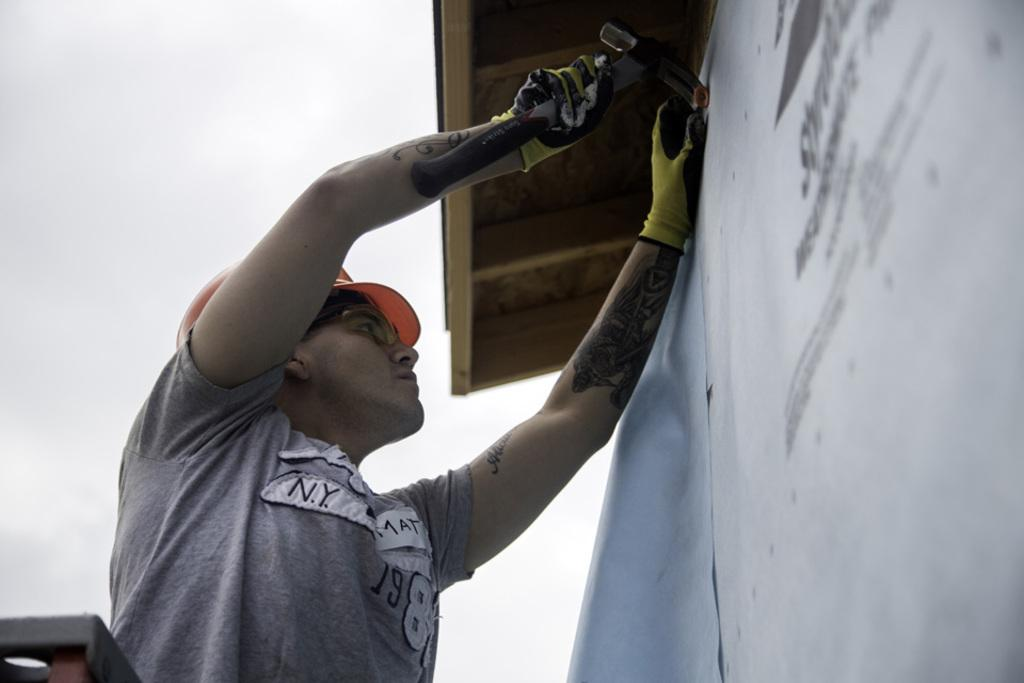What is the person in the image doing? The person is holding a hammer and hitting a nail in the wall. What object is the person using to hit the nail? The person is using a hammer to hit the nail. What type of material is visible at the top of the image? There is a wooden roof visible at the top of the image. What type of plough is being used to prepare the ground in the image? There is no plough present in the image; it features a person using a hammer to hit a nail in the wall. What type of calendar is hanging on the wall next to the person in the image? There is no calendar visible in the image; it only shows a person hitting a nail in the wall with a hammer and a wooden roof at the top. 